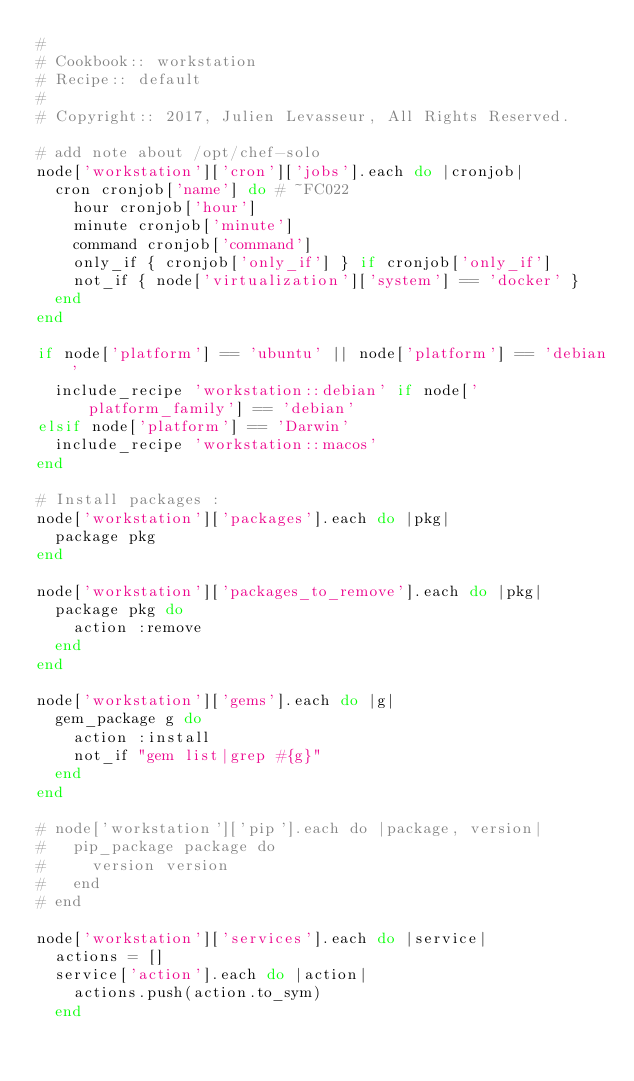Convert code to text. <code><loc_0><loc_0><loc_500><loc_500><_Ruby_>#
# Cookbook:: workstation
# Recipe:: default
#
# Copyright:: 2017, Julien Levasseur, All Rights Reserved.

# add note about /opt/chef-solo
node['workstation']['cron']['jobs'].each do |cronjob|
  cron cronjob['name'] do # ~FC022
    hour cronjob['hour']
    minute cronjob['minute']
    command cronjob['command']
    only_if { cronjob['only_if'] } if cronjob['only_if']
    not_if { node['virtualization']['system'] == 'docker' }
  end
end

if node['platform'] == 'ubuntu' || node['platform'] == 'debian'
  include_recipe 'workstation::debian' if node['platform_family'] == 'debian'
elsif node['platform'] == 'Darwin'
  include_recipe 'workstation::macos'
end

# Install packages :
node['workstation']['packages'].each do |pkg|
  package pkg
end

node['workstation']['packages_to_remove'].each do |pkg|
  package pkg do
    action :remove
  end
end

node['workstation']['gems'].each do |g|
  gem_package g do
    action :install
    not_if "gem list|grep #{g}"
  end
end

# node['workstation']['pip'].each do |package, version|
#   pip_package package do
#     version version
#   end
# end

node['workstation']['services'].each do |service|
  actions = []
  service['action'].each do |action|
    actions.push(action.to_sym)
  end</code> 